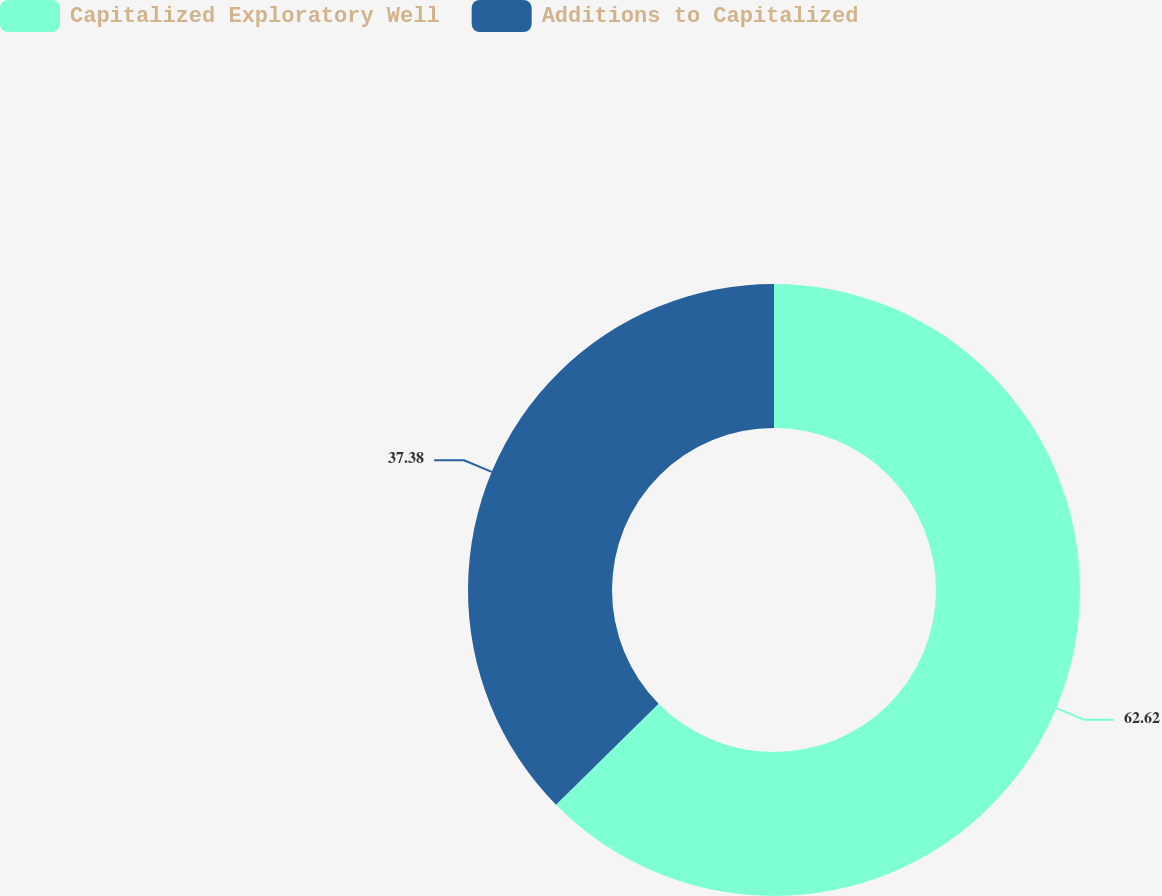<chart> <loc_0><loc_0><loc_500><loc_500><pie_chart><fcel>Capitalized Exploratory Well<fcel>Additions to Capitalized<nl><fcel>62.62%<fcel>37.38%<nl></chart> 